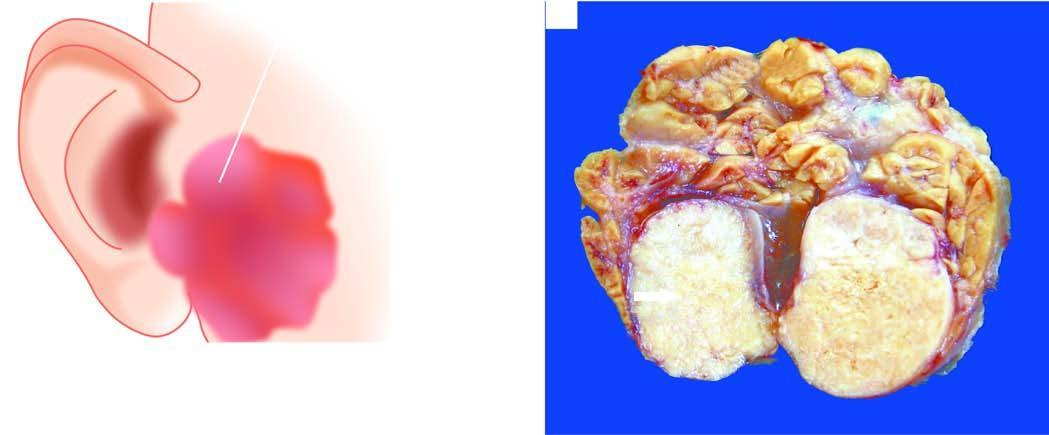what shows lobules of grey-white circumscribed tumour having semitranslucent parenchyma?
Answer the question using a single word or phrase. Sectioned surface the parotid gland 